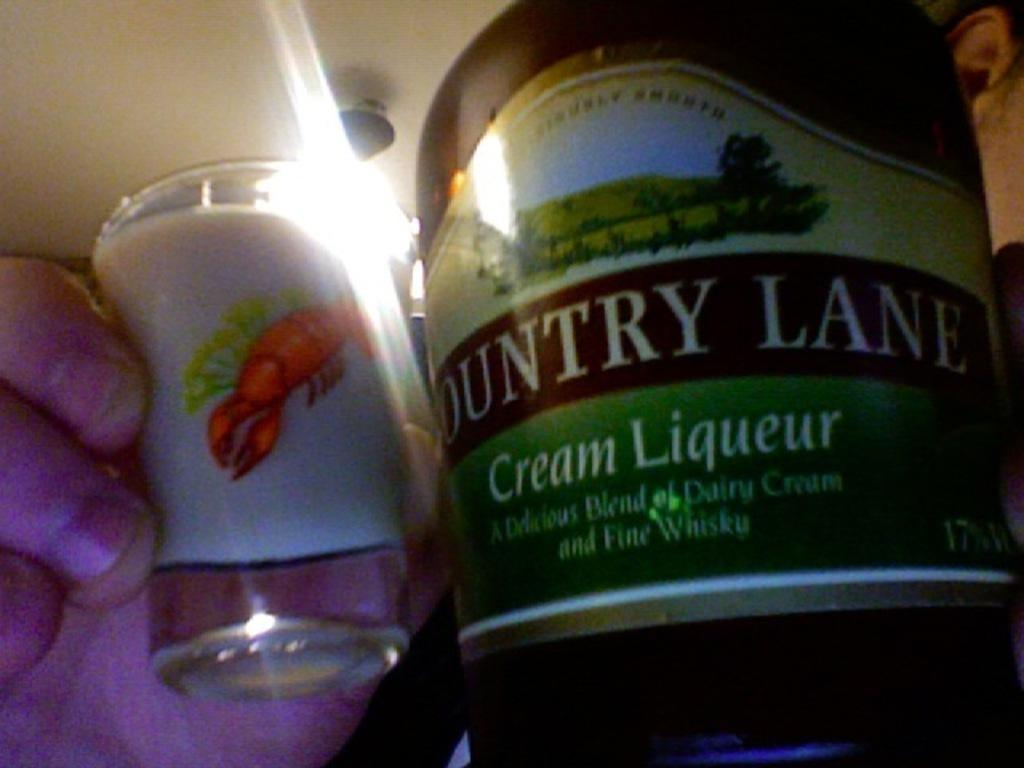What is one object visible in the image? There is a bottle in the image. What is another object visible in the image? There is a glass in the image. How many bears are sitting on top of the bucket in the image? There is no bucket or bears present in the image. What color is the balloon tied to the glass in the image? There is no balloon present in the image. 